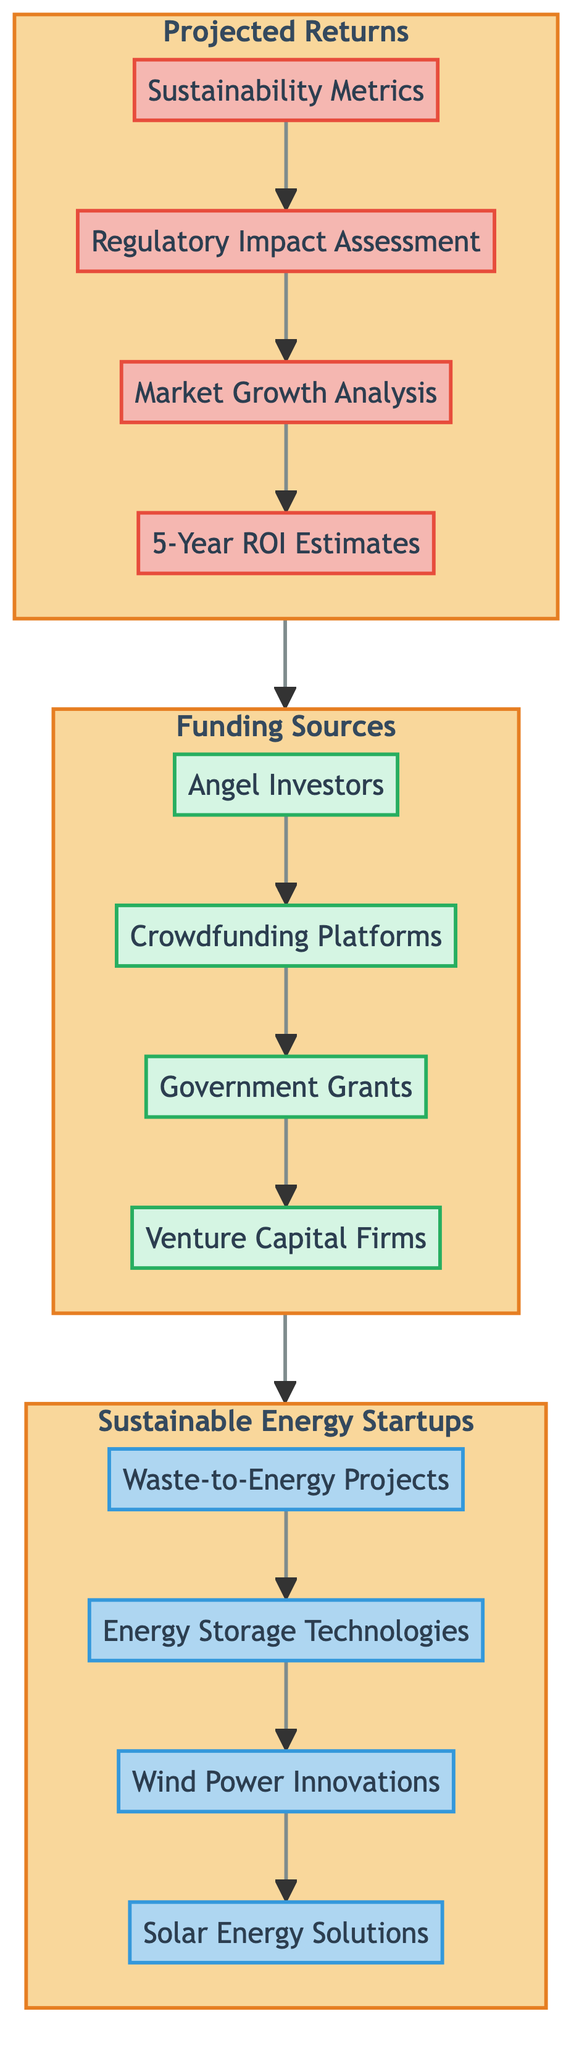What are the types of funding sources listed in the diagram? The diagram lists four funding sources: Angel Investors, Crowdfunding Platforms, Government Grants, and Venture Capital Firms.
Answer: Angel Investors, Crowdfunding Platforms, Government Grants, Venture Capital Firms How many sustainable energy startups are depicted in the diagram? There are four sustainable energy startups shown: Solar Energy Solutions, Wind Power Innovations, Energy Storage Technologies, and Waste-to-Energy Projects.
Answer: Four What is the last node in the "Projected Returns" section? The last node that appears in the "Projected Returns" section is "5-Year ROI Estimates." This is determined by following the sequence from Sustainability Metrics down to 5-Year ROI Estimates.
Answer: 5-Year ROI Estimates What is the flow direction of the Funding Sources to Sustainable Energy Startups? Funding Sources flow into the Sustainable Energy Startups, indicating a downward movement in the diagram from Funding Sources to Sustainable Energy Startups.
Answer: Downward Which two categories connect directly in this flow chart? The "Projected Returns" category connects directly to the "Funding Sources" category and the "Funding Sources" connects directly to the "Sustainable Energy Startups" category.
Answer: Projected Returns and Funding Sources How many nodes are in the "Funding Sources" category? The "Funding Sources" category comprises four nodes: Angel Investors, Crowdfunding Platforms, Government Grants, and Venture Capital Firms.
Answer: Four Which funding source comes first in the flow? The first funding source in the flow is "Angel Investors," as it starts the sequence in the Funding Sources category.
Answer: Angel Investors What type of relationships do the nodes in the diagram represent? The nodes represent a hierarchical structure where categories and their respective elements flow into one another, showing a dependency from funding sources to startup projections.
Answer: Hierarchical relationships Which category has the most nodes in the diagram? The category with the most nodes is "Sustainable Energy Startups," which has four distinct startup types.
Answer: Sustainable Energy Startups 